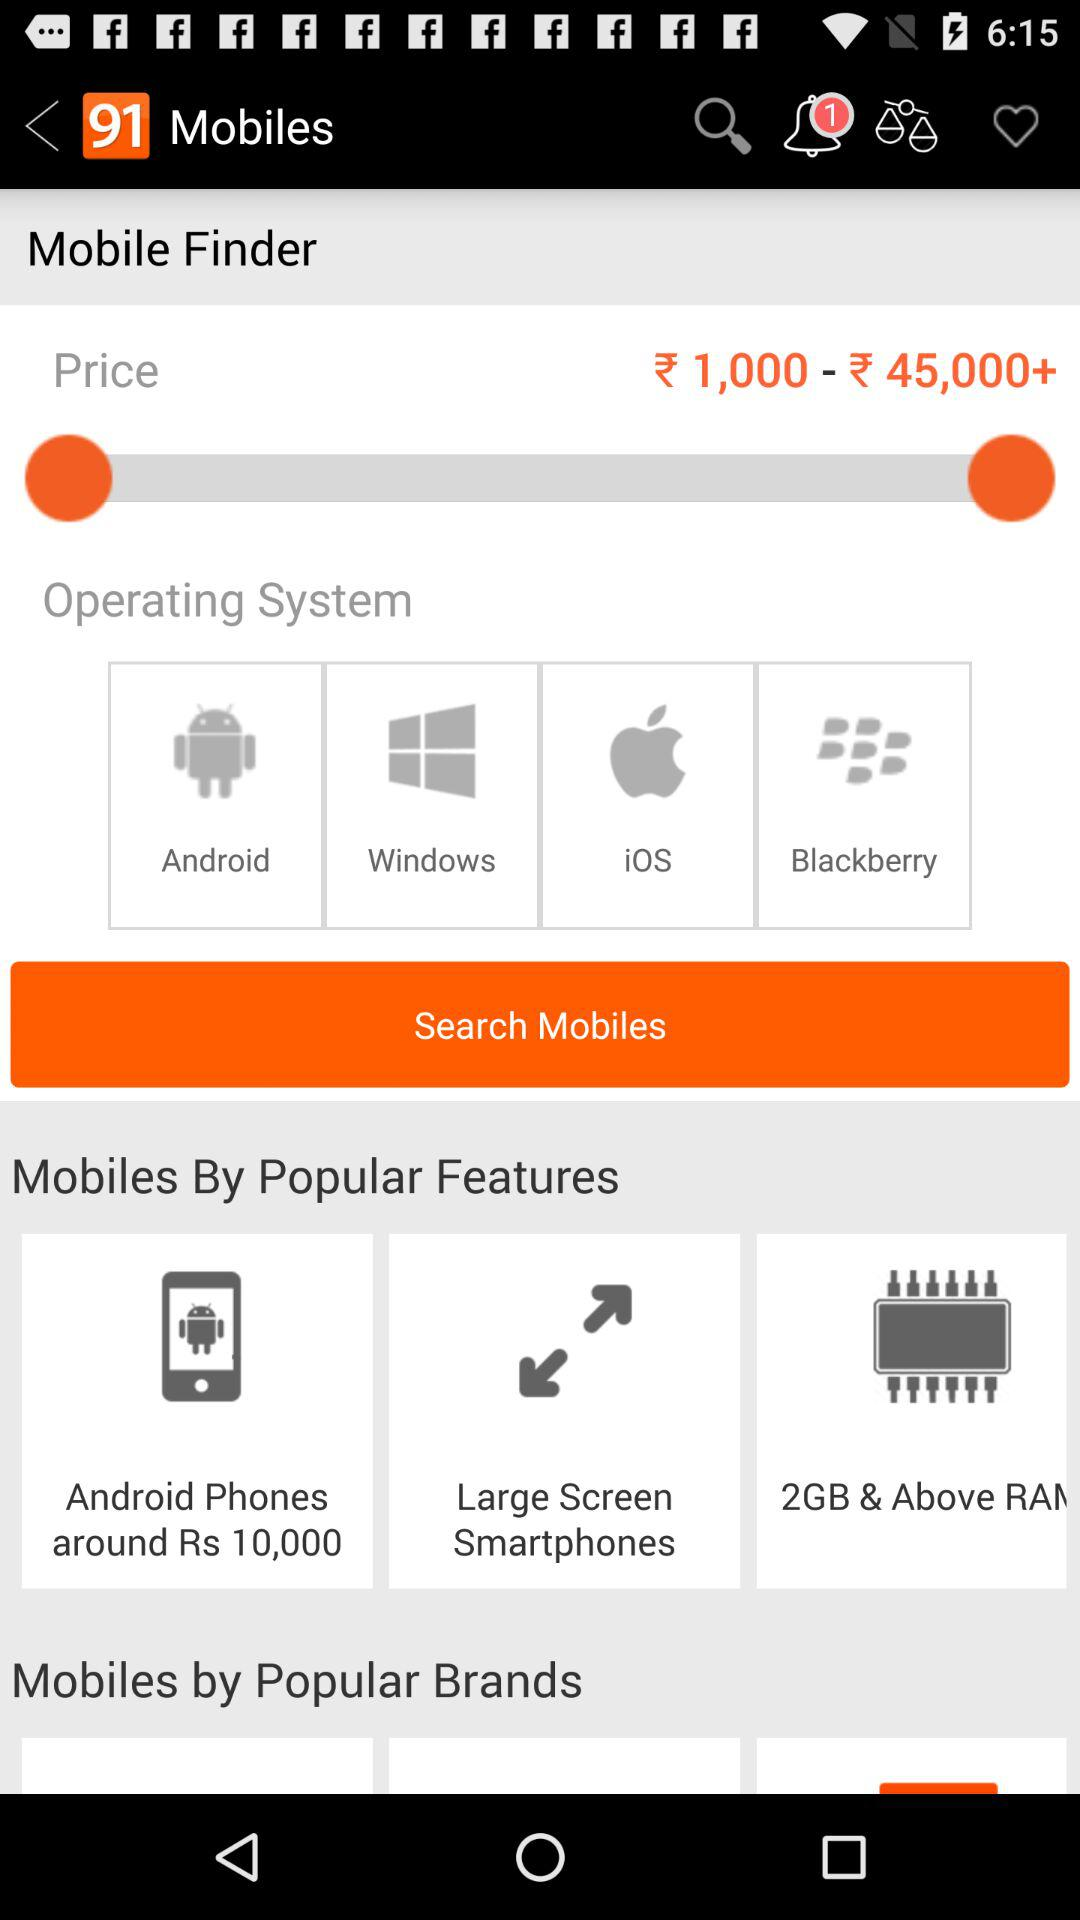What are the popular features? The popular features are "Android Phones around Rs 10,000", "Large Screen Smartphones" and "2GB & Above RAM". 